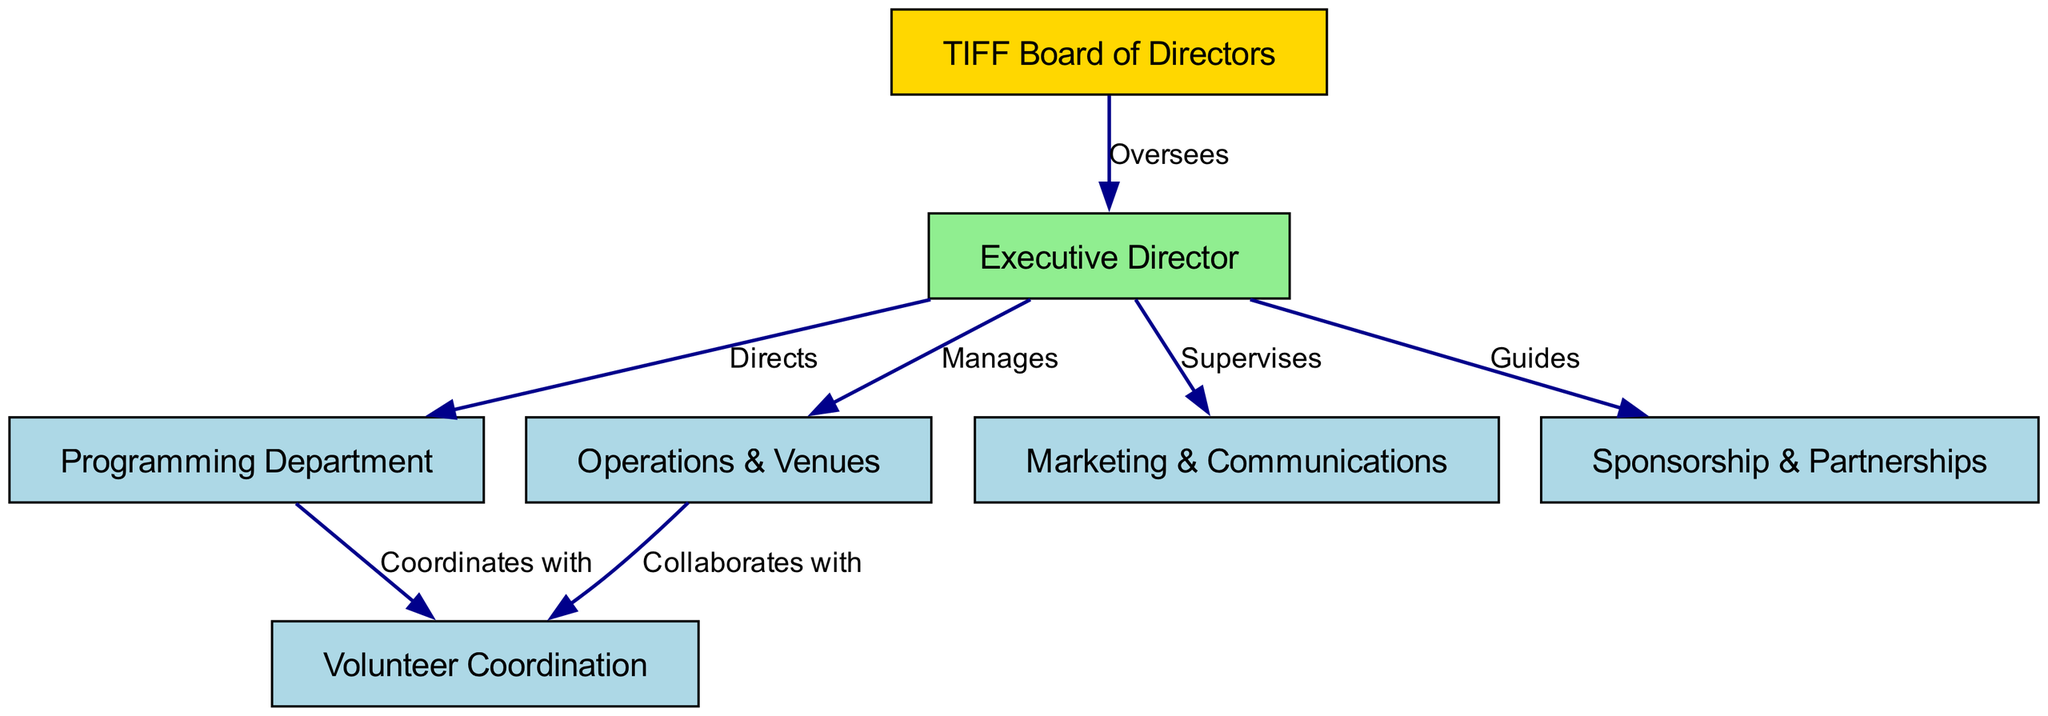What is the highest-level node in the diagram? The highest-level node is the "TIFF Board of Directors," as it is the only node that does not have any incoming edges from other nodes, indicating it oversees the overall structure.
Answer: TIFF Board of Directors How many nodes are present in total? The diagram lists eight nodes, which include the TIFF Board of Directors, Executive Director, Programming Department, Operations & Venues, Marketing & Communications, Sponsorship & Partnerships, and Volunteer Coordination.
Answer: 7 Which department does the Executive Director oversee? The Executive Director oversees the "TIFF Board of Directors," which is indicated by the edge labeled "Oversees" that connects them, establishing the highest level of authority in the organization.
Answer: Executive Director What is the relationship between the Programming Department and Volunteer Coordination? The programming department "Coordinates with" Volunteer Coordination, as shown by the directed edge connecting these two nodes in the diagram, indicating a collaborative relationship in their roles.
Answer: Coordinates with How many departments does the Executive Director manage? The Executive Director manages four departments: Programming Department, Operations & Venues, Marketing & Communications, and Sponsorship & Partnerships, as inferred from the connections illustrated in the diagram.
Answer: 4 Who collaborates with the Volunteer Coordination department? Both the Programming Department and Operations & Venues collaborate with Volunteer Coordination, as both have directed edges leading to it, establishing interdisciplinary support for the volunteer efforts.
Answer: Programming Department and Operations & Venues What role does the Executive Director have in relation to Sponsorship & Partnerships? The Executive Director "Guides" the Sponsorship & Partnerships department, as indicated by the edge labeled "Guides," showing a supervisory or directional capacity.
Answer: Guides Which department is responsible for marketing in the TIFF structure? The Marketing & Communications department is responsible for marketing, as directly labeled in the diagram and indicated by its connection to the Executive Director, illustrating its function within event planning.
Answer: Marketing & Communications 